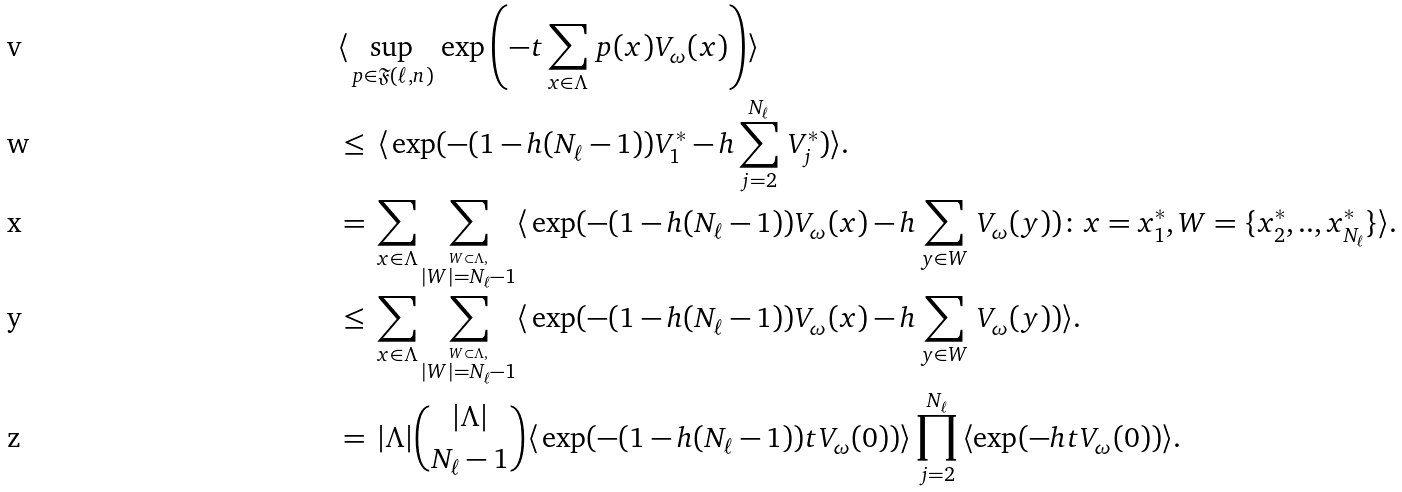Convert formula to latex. <formula><loc_0><loc_0><loc_500><loc_500>& \langle \, \sup _ { p \in \mathfrak { F } ( \ell , n ) } \, \exp \left ( - t \sum _ { x \in \Lambda } \, p ( x ) V _ { \omega } ( x ) \right ) \rangle \\ & \leq \, \langle \, \exp ( - ( 1 - h ( N _ { \ell } - 1 ) ) V _ { 1 } ^ { * } - h \sum _ { j = 2 } ^ { N _ { \ell } } \, V ^ { * } _ { j } ) \rangle . \\ & = \, \sum _ { x \in \Lambda } \sum _ { \overset { W \subset \Lambda , } { | W | = N _ { \ell } - 1 } } \langle \, \exp ( - ( 1 - h ( N _ { \ell } - 1 ) ) V _ { \omega } ( x ) - h \sum _ { y \in W } \, V _ { \omega } ( y ) ) \colon x = x ^ { * } _ { 1 } , W = \{ x ^ { * } _ { 2 } , . . , x ^ { * } _ { N _ { \ell } } \} \rangle . \\ & \leq \, \sum _ { x \in \Lambda } \sum _ { \overset { W \subset \Lambda , } { | W | = N _ { \ell } - 1 } } \langle \, \exp ( - ( 1 - h ( N _ { \ell } - 1 ) ) V _ { \omega } ( x ) - h \sum _ { y \in W } \, V _ { \omega } ( y ) ) \rangle . \\ & = \, | \Lambda | \binom { | \Lambda | } { N _ { \ell } - 1 } \langle \, \exp ( - ( 1 - h ( N _ { \ell } - 1 ) ) t V _ { \omega } ( 0 ) ) \rangle \prod _ { j = 2 } ^ { N _ { \ell } } \, \langle \exp ( - h t V _ { \omega } ( 0 ) ) \rangle .</formula> 